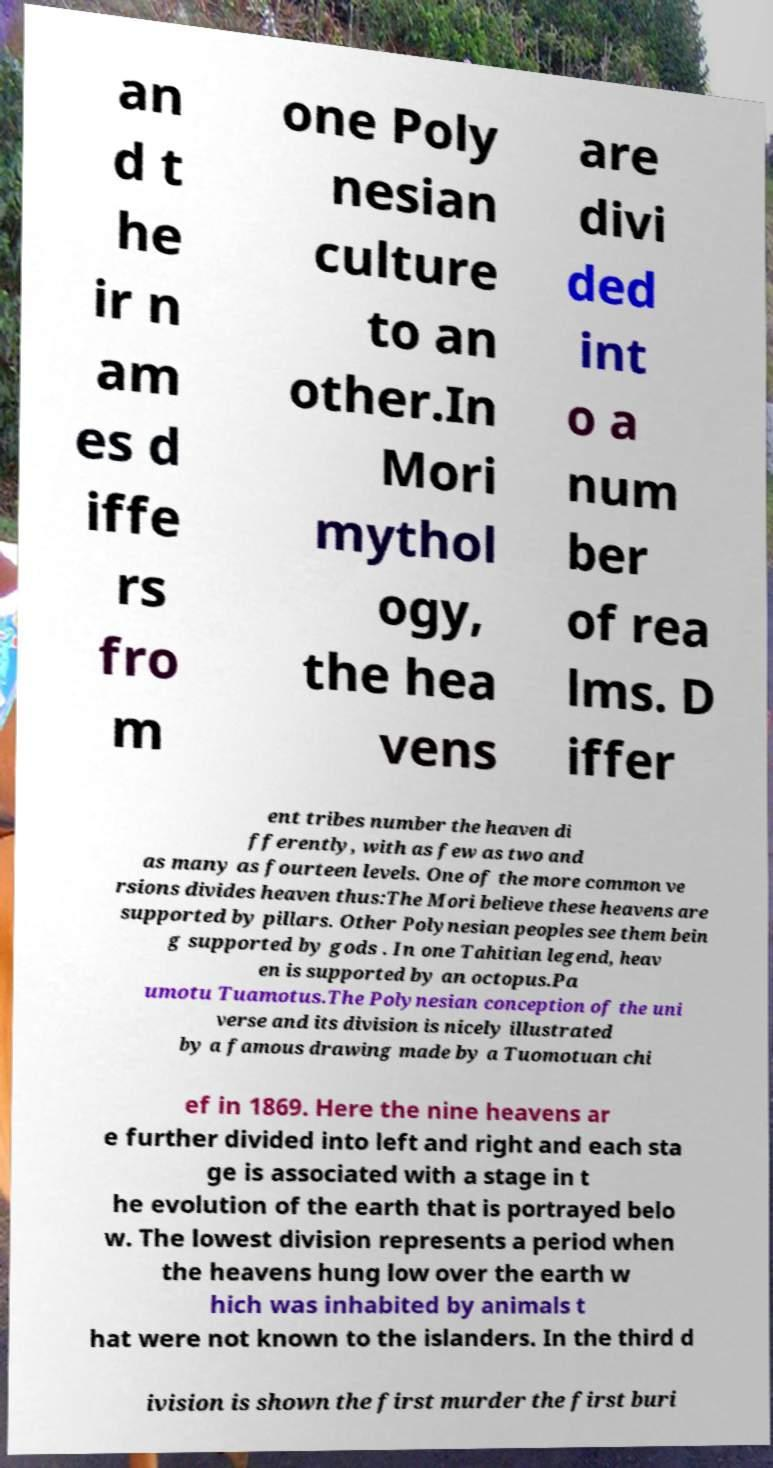I need the written content from this picture converted into text. Can you do that? an d t he ir n am es d iffe rs fro m one Poly nesian culture to an other.In Mori mythol ogy, the hea vens are divi ded int o a num ber of rea lms. D iffer ent tribes number the heaven di fferently, with as few as two and as many as fourteen levels. One of the more common ve rsions divides heaven thus:The Mori believe these heavens are supported by pillars. Other Polynesian peoples see them bein g supported by gods . In one Tahitian legend, heav en is supported by an octopus.Pa umotu Tuamotus.The Polynesian conception of the uni verse and its division is nicely illustrated by a famous drawing made by a Tuomotuan chi ef in 1869. Here the nine heavens ar e further divided into left and right and each sta ge is associated with a stage in t he evolution of the earth that is portrayed belo w. The lowest division represents a period when the heavens hung low over the earth w hich was inhabited by animals t hat were not known to the islanders. In the third d ivision is shown the first murder the first buri 